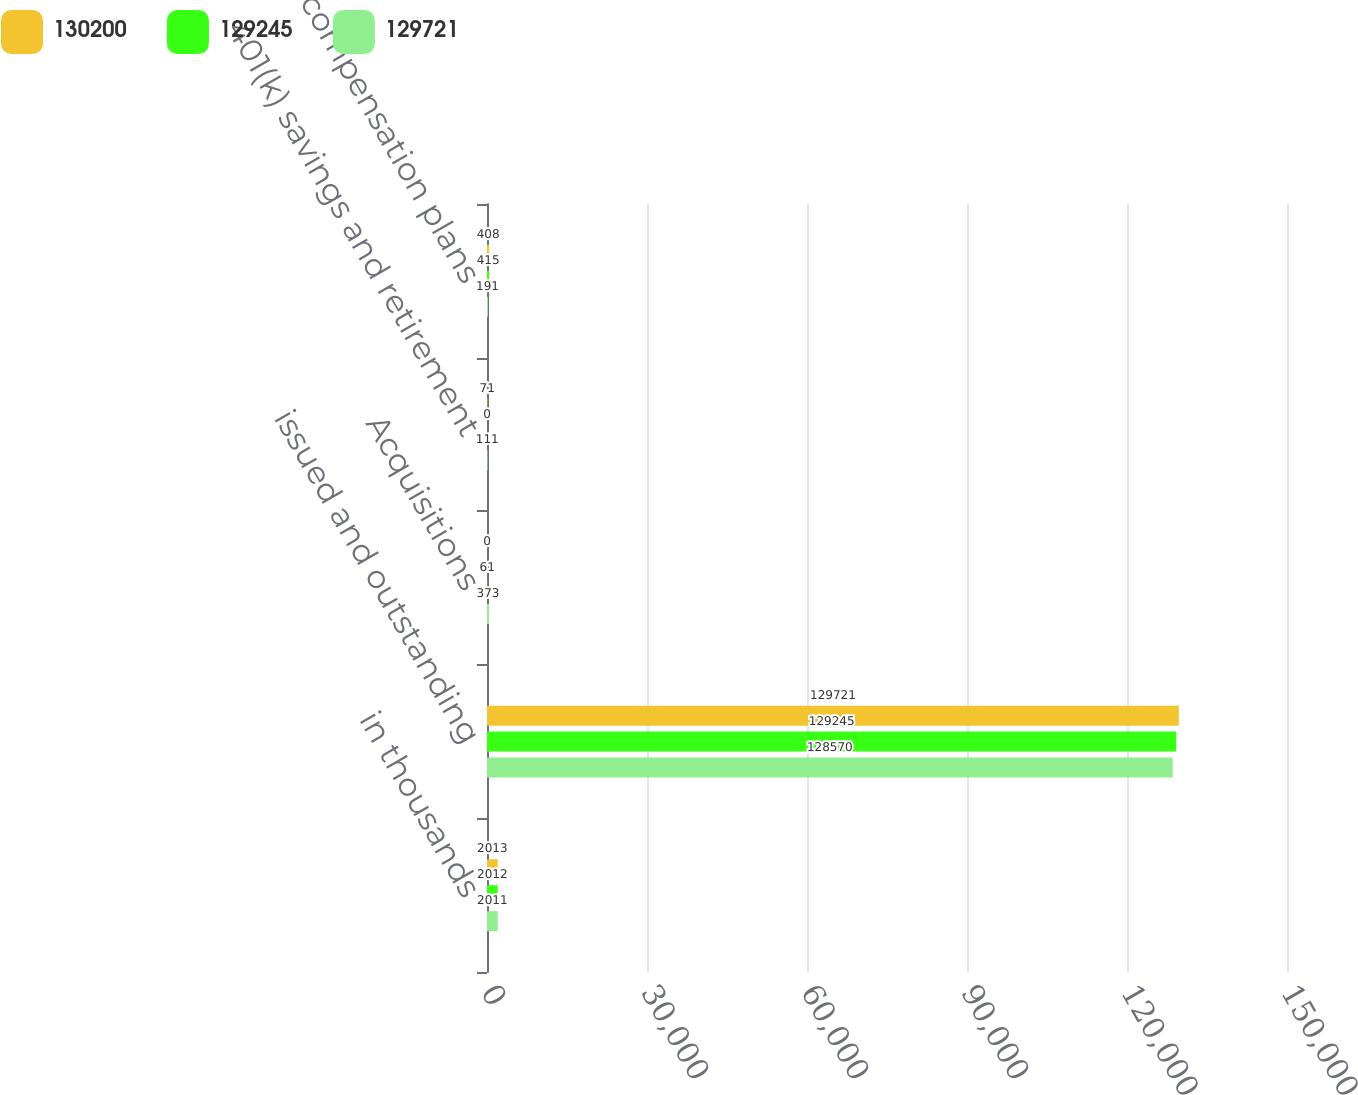Convert chart to OTSL. <chart><loc_0><loc_0><loc_500><loc_500><stacked_bar_chart><ecel><fcel>in thousands<fcel>issued and outstanding<fcel>Acquisitions<fcel>401(k) savings and retirement<fcel>Share-based compensation plans<nl><fcel>130200<fcel>2013<fcel>129721<fcel>0<fcel>71<fcel>408<nl><fcel>129245<fcel>2012<fcel>129245<fcel>61<fcel>0<fcel>415<nl><fcel>129721<fcel>2011<fcel>128570<fcel>373<fcel>111<fcel>191<nl></chart> 